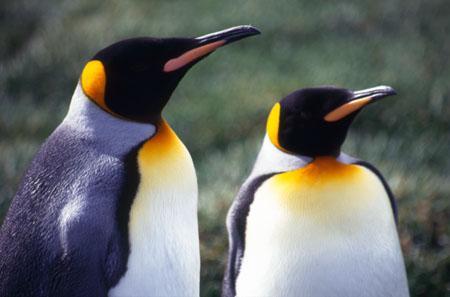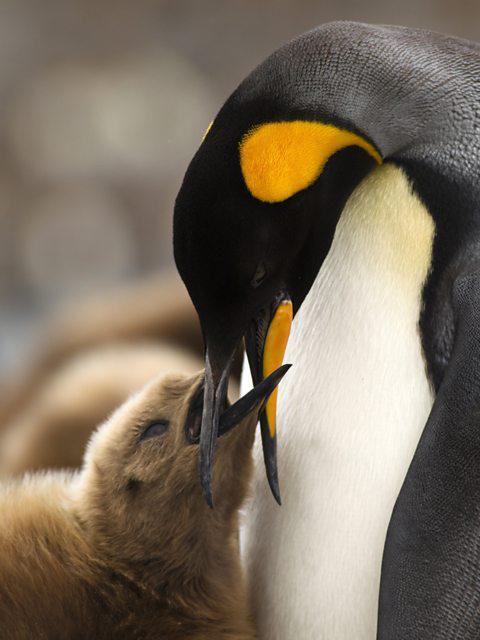The first image is the image on the left, the second image is the image on the right. Analyze the images presented: Is the assertion "There are two penguins facing the same direction in the left image." valid? Answer yes or no. Yes. The first image is the image on the left, the second image is the image on the right. Evaluate the accuracy of this statement regarding the images: "One penguin is touching another penguins beak with its beak.". Is it true? Answer yes or no. Yes. 